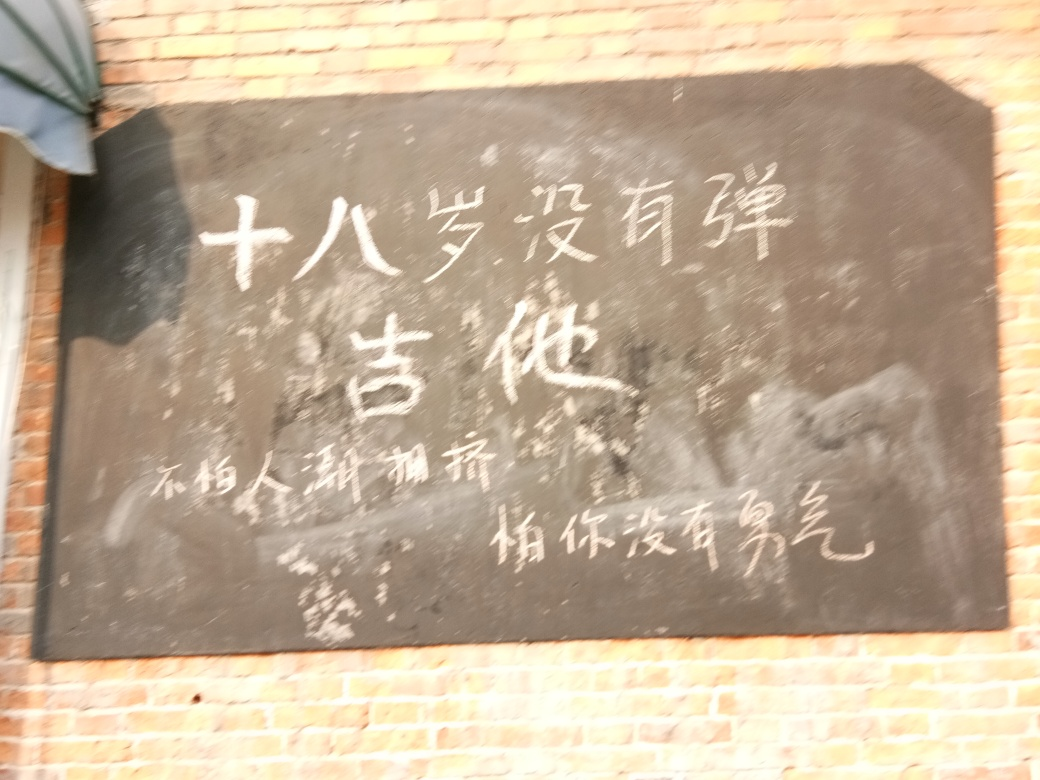Is the contrast level appropriate? Based on the provided image, which appears to be a blackboard with handwritten text, the contrast level seems suboptimal. The image is blurred, and the lighting conditions may be exacerbating the lack of clarity. An ideal contrast level would allow the text to stand out clearly against the blackboard, facilitating legibility. 